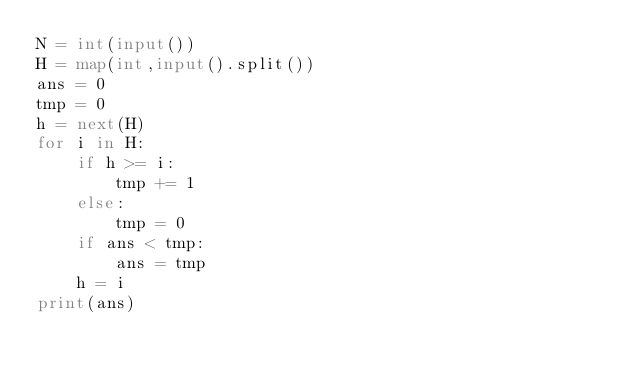Convert code to text. <code><loc_0><loc_0><loc_500><loc_500><_Python_>N = int(input())
H = map(int,input().split())
ans = 0
tmp = 0
h = next(H)
for i in H:
    if h >= i:
        tmp += 1
    else:
        tmp = 0
    if ans < tmp:
        ans = tmp
    h = i
print(ans)</code> 